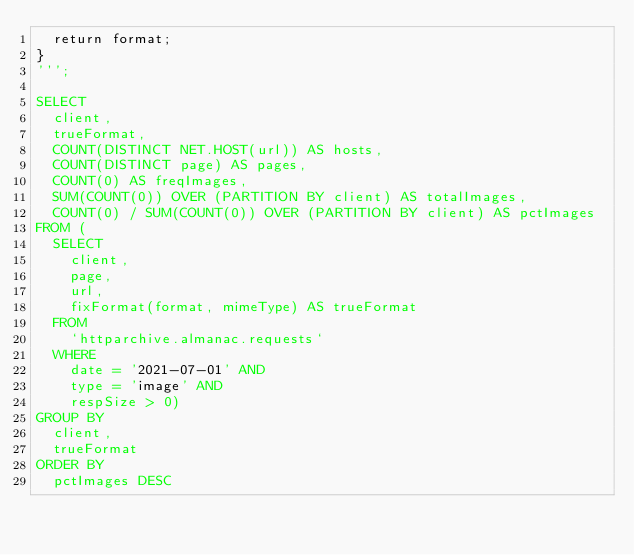Convert code to text. <code><loc_0><loc_0><loc_500><loc_500><_SQL_>  return format;
}
''';

SELECT
  client,
  trueFormat,
  COUNT(DISTINCT NET.HOST(url)) AS hosts,
  COUNT(DISTINCT page) AS pages,
  COUNT(0) AS freqImages,
  SUM(COUNT(0)) OVER (PARTITION BY client) AS totalImages,
  COUNT(0) / SUM(COUNT(0)) OVER (PARTITION BY client) AS pctImages
FROM (
  SELECT
    client,
    page,
    url,
    fixFormat(format, mimeType) AS trueFormat
  FROM
    `httparchive.almanac.requests`
  WHERE
    date = '2021-07-01' AND
    type = 'image' AND
    respSize > 0)
GROUP BY
  client,
  trueFormat
ORDER BY
  pctImages DESC
</code> 